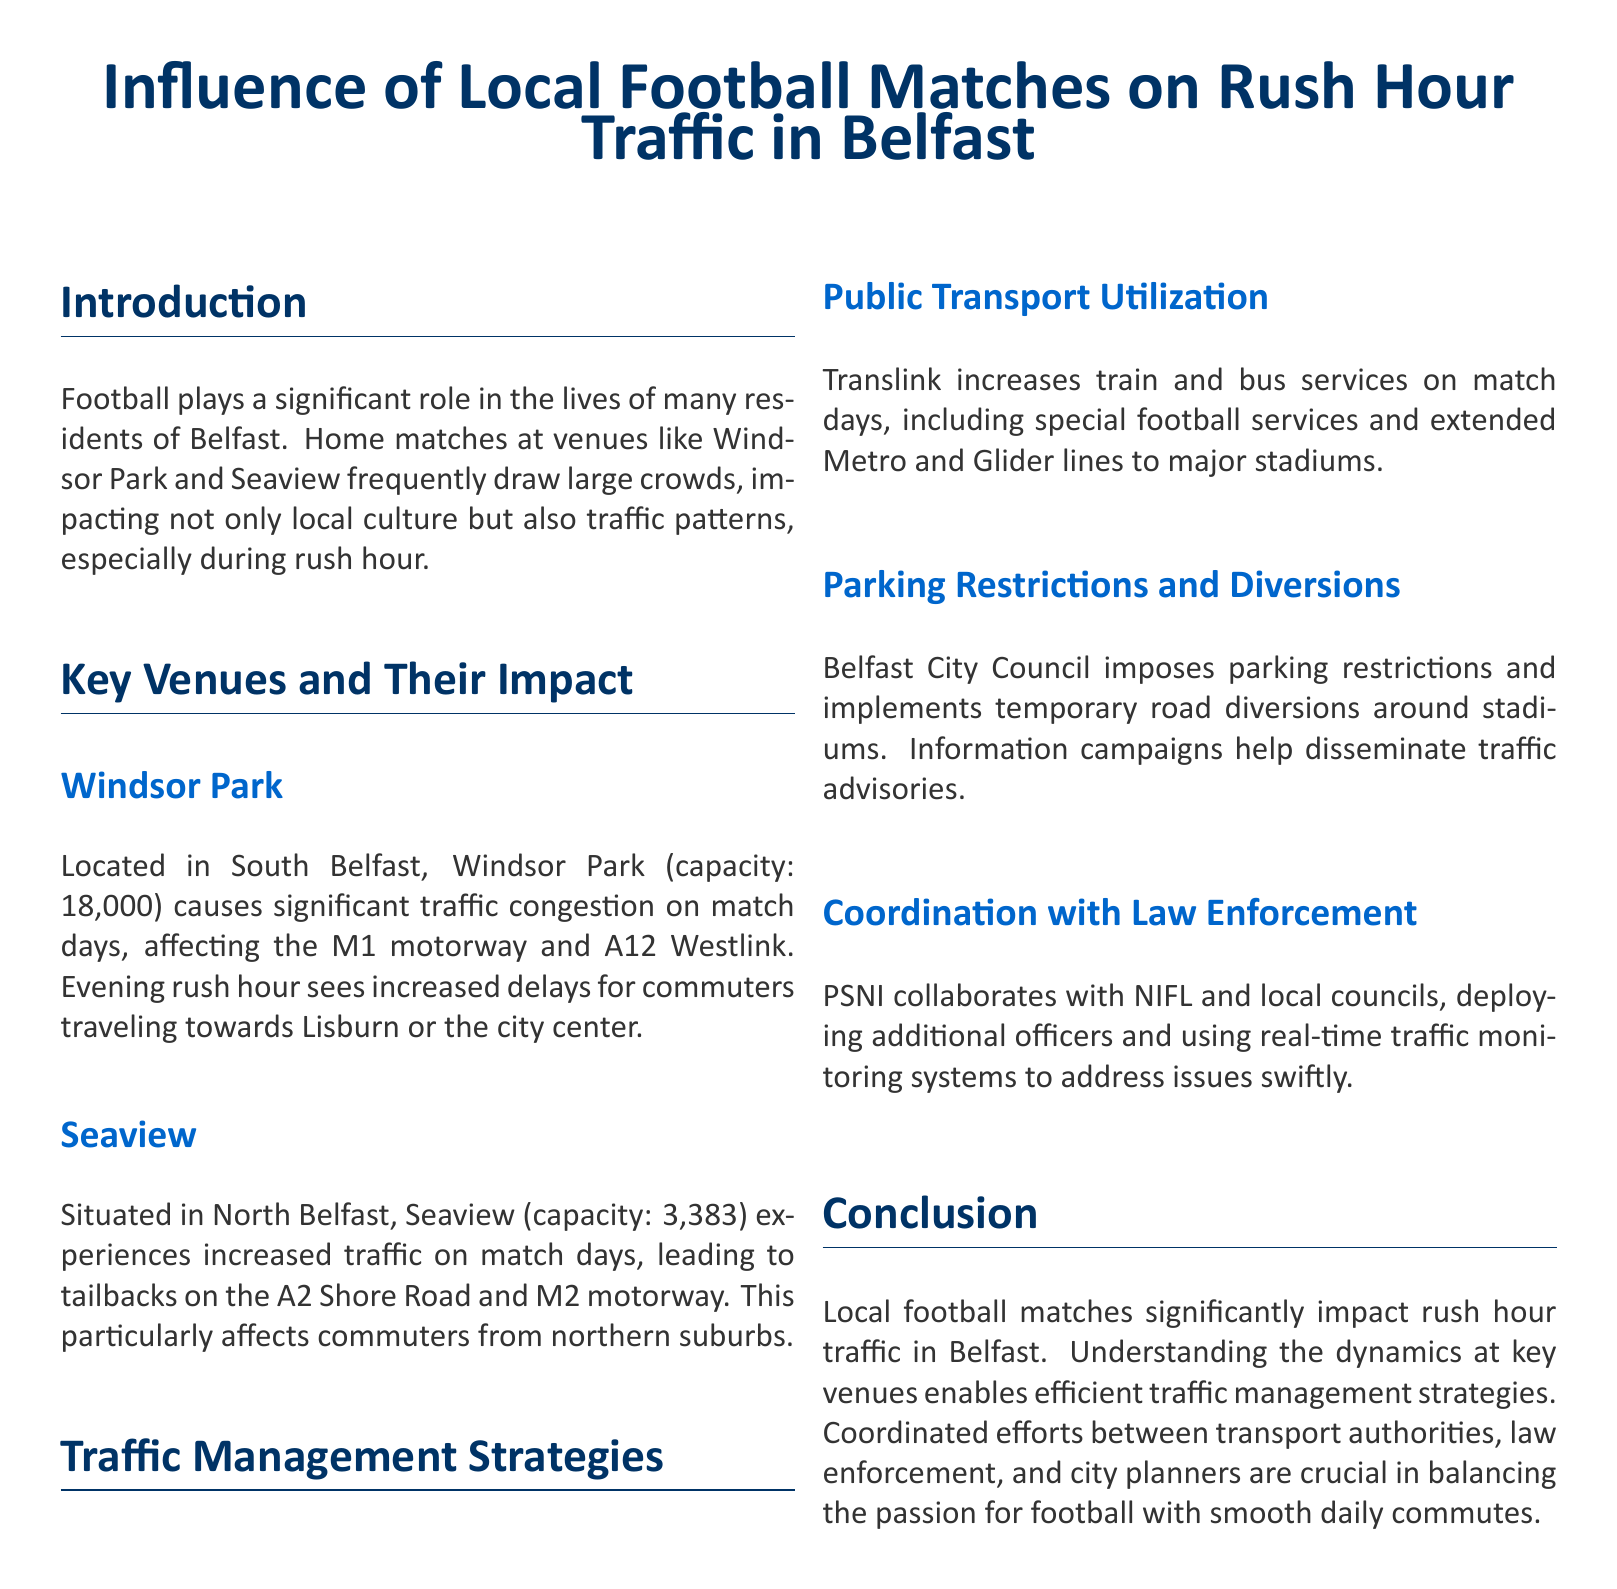What is the capacity of Windsor Park? The capacity of Windsor Park is mentioned directly in the document under "Windsor Park."
Answer: 18,000 What is the impact of Seaview on rush hour traffic? The document states that Seaview causes increased traffic leading to tailbacks on specific roads, which is discussed in the "Seaview" section.
Answer: Tailbacks What organization collaborates with PSNI for traffic management? The document mentions that PSNI collaborates with a specific league which is named in the "Coordination with Law Enforcement" section.
Answer: NIFL Which road experiences delays due to Windsor Park events? The document specifies that the M1 motorway is affected by traffic congestion from Windsor Park on match days.
Answer: M1 motorway What is a strategy used for managing traffic on match days? The document outlines multiple strategies, with one being increasing public transport services, which is discussed in detail.
Answer: Public Transport Utilization How does the city council assist with traffic issues? The document notes certain measures taken by the Belfast City Council detailed under "Parking Restrictions and Diversions."
Answer: Parking restrictions What time of day sees increased delays due to Windsor Park matches? The document indicates that evening rush hour sees delays due to matches at Windsor Park.
Answer: Evening rush hour What traffic monitoring system is mentioned in the document? The document refers to real-time traffic monitoring systems used in coordination with law enforcement.
Answer: Real-time traffic monitoring systems What is the main focus of the report? The document aims to investigate the impact of local football matches specifically on rush hour traffic in Belfast.
Answer: Influence of Local Football Matches 